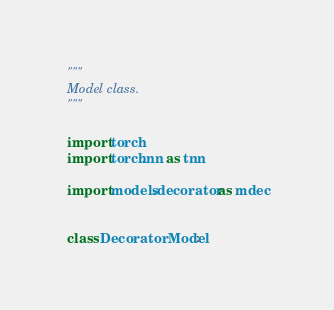Convert code to text. <code><loc_0><loc_0><loc_500><loc_500><_Python_>"""
Model class.
"""

import torch
import torch.nn as tnn

import models.decorator as mdec


class DecoratorModel:
</code> 